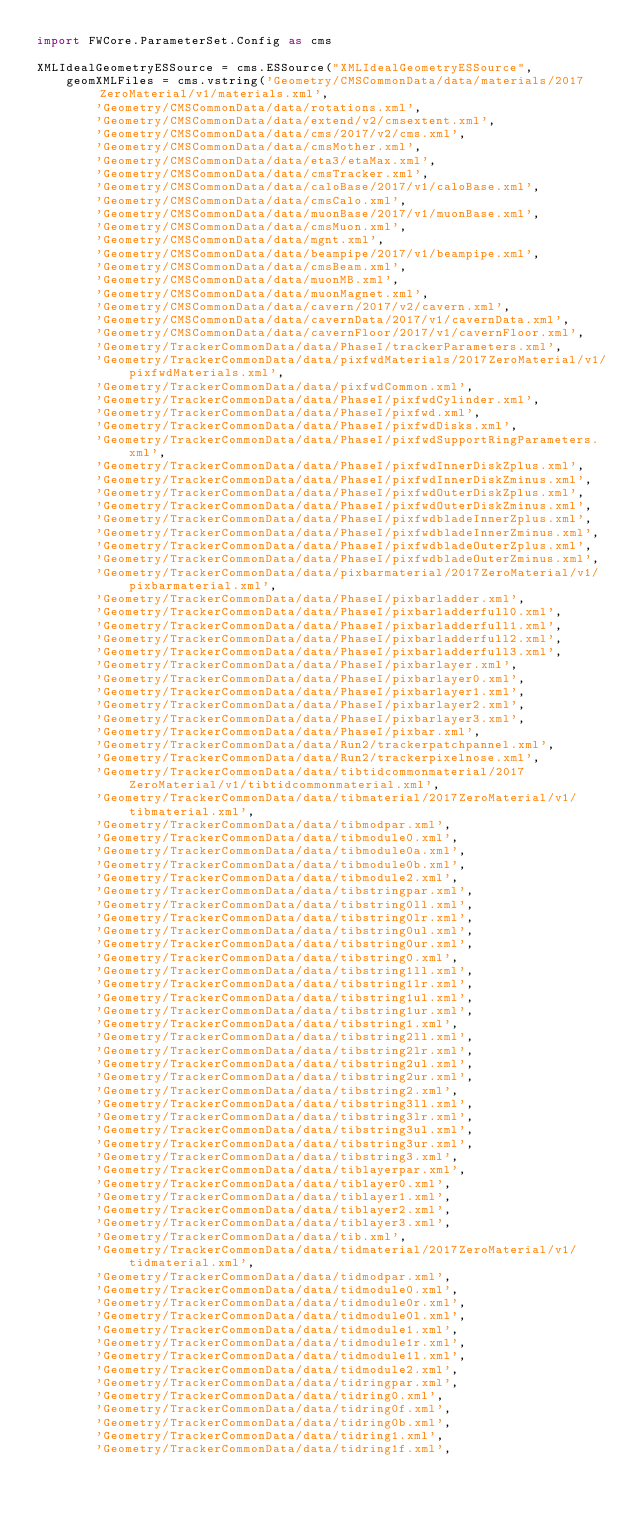<code> <loc_0><loc_0><loc_500><loc_500><_Python_>import FWCore.ParameterSet.Config as cms

XMLIdealGeometryESSource = cms.ESSource("XMLIdealGeometryESSource",
    geomXMLFiles = cms.vstring('Geometry/CMSCommonData/data/materials/2017ZeroMaterial/v1/materials.xml',
        'Geometry/CMSCommonData/data/rotations.xml',
        'Geometry/CMSCommonData/data/extend/v2/cmsextent.xml',
        'Geometry/CMSCommonData/data/cms/2017/v2/cms.xml',
        'Geometry/CMSCommonData/data/cmsMother.xml',
        'Geometry/CMSCommonData/data/eta3/etaMax.xml',
        'Geometry/CMSCommonData/data/cmsTracker.xml',
        'Geometry/CMSCommonData/data/caloBase/2017/v1/caloBase.xml',
        'Geometry/CMSCommonData/data/cmsCalo.xml',
        'Geometry/CMSCommonData/data/muonBase/2017/v1/muonBase.xml',
        'Geometry/CMSCommonData/data/cmsMuon.xml',
        'Geometry/CMSCommonData/data/mgnt.xml',
        'Geometry/CMSCommonData/data/beampipe/2017/v1/beampipe.xml',
        'Geometry/CMSCommonData/data/cmsBeam.xml',
        'Geometry/CMSCommonData/data/muonMB.xml',
        'Geometry/CMSCommonData/data/muonMagnet.xml',
        'Geometry/CMSCommonData/data/cavern/2017/v2/cavern.xml',
        'Geometry/CMSCommonData/data/cavernData/2017/v1/cavernData.xml',
        'Geometry/CMSCommonData/data/cavernFloor/2017/v1/cavernFloor.xml',
        'Geometry/TrackerCommonData/data/PhaseI/trackerParameters.xml',
        'Geometry/TrackerCommonData/data/pixfwdMaterials/2017ZeroMaterial/v1/pixfwdMaterials.xml',
        'Geometry/TrackerCommonData/data/pixfwdCommon.xml',
        'Geometry/TrackerCommonData/data/PhaseI/pixfwdCylinder.xml', 
        'Geometry/TrackerCommonData/data/PhaseI/pixfwd.xml', 
        'Geometry/TrackerCommonData/data/PhaseI/pixfwdDisks.xml', 
        'Geometry/TrackerCommonData/data/PhaseI/pixfwdSupportRingParameters.xml',
        'Geometry/TrackerCommonData/data/PhaseI/pixfwdInnerDiskZplus.xml',
        'Geometry/TrackerCommonData/data/PhaseI/pixfwdInnerDiskZminus.xml',
        'Geometry/TrackerCommonData/data/PhaseI/pixfwdOuterDiskZplus.xml',
        'Geometry/TrackerCommonData/data/PhaseI/pixfwdOuterDiskZminus.xml',
        'Geometry/TrackerCommonData/data/PhaseI/pixfwdbladeInnerZplus.xml',
        'Geometry/TrackerCommonData/data/PhaseI/pixfwdbladeInnerZminus.xml',
        'Geometry/TrackerCommonData/data/PhaseI/pixfwdbladeOuterZplus.xml',
        'Geometry/TrackerCommonData/data/PhaseI/pixfwdbladeOuterZminus.xml',
        'Geometry/TrackerCommonData/data/pixbarmaterial/2017ZeroMaterial/v1/pixbarmaterial.xml', 
        'Geometry/TrackerCommonData/data/PhaseI/pixbarladder.xml', 
        'Geometry/TrackerCommonData/data/PhaseI/pixbarladderfull0.xml', 
        'Geometry/TrackerCommonData/data/PhaseI/pixbarladderfull1.xml', 
        'Geometry/TrackerCommonData/data/PhaseI/pixbarladderfull2.xml', 
        'Geometry/TrackerCommonData/data/PhaseI/pixbarladderfull3.xml', 
        'Geometry/TrackerCommonData/data/PhaseI/pixbarlayer.xml', 
        'Geometry/TrackerCommonData/data/PhaseI/pixbarlayer0.xml', 
        'Geometry/TrackerCommonData/data/PhaseI/pixbarlayer1.xml', 
        'Geometry/TrackerCommonData/data/PhaseI/pixbarlayer2.xml', 
        'Geometry/TrackerCommonData/data/PhaseI/pixbarlayer3.xml', 
        'Geometry/TrackerCommonData/data/PhaseI/pixbar.xml',
        'Geometry/TrackerCommonData/data/Run2/trackerpatchpannel.xml',
        'Geometry/TrackerCommonData/data/Run2/trackerpixelnose.xml',
        'Geometry/TrackerCommonData/data/tibtidcommonmaterial/2017ZeroMaterial/v1/tibtidcommonmaterial.xml',
        'Geometry/TrackerCommonData/data/tibmaterial/2017ZeroMaterial/v1/tibmaterial.xml',
        'Geometry/TrackerCommonData/data/tibmodpar.xml',
        'Geometry/TrackerCommonData/data/tibmodule0.xml',
        'Geometry/TrackerCommonData/data/tibmodule0a.xml',
        'Geometry/TrackerCommonData/data/tibmodule0b.xml',
        'Geometry/TrackerCommonData/data/tibmodule2.xml',
        'Geometry/TrackerCommonData/data/tibstringpar.xml',
        'Geometry/TrackerCommonData/data/tibstring0ll.xml',
        'Geometry/TrackerCommonData/data/tibstring0lr.xml',
        'Geometry/TrackerCommonData/data/tibstring0ul.xml',
        'Geometry/TrackerCommonData/data/tibstring0ur.xml',
        'Geometry/TrackerCommonData/data/tibstring0.xml',
        'Geometry/TrackerCommonData/data/tibstring1ll.xml',
        'Geometry/TrackerCommonData/data/tibstring1lr.xml',
        'Geometry/TrackerCommonData/data/tibstring1ul.xml',
        'Geometry/TrackerCommonData/data/tibstring1ur.xml',
        'Geometry/TrackerCommonData/data/tibstring1.xml',
        'Geometry/TrackerCommonData/data/tibstring2ll.xml',
        'Geometry/TrackerCommonData/data/tibstring2lr.xml',
        'Geometry/TrackerCommonData/data/tibstring2ul.xml',
        'Geometry/TrackerCommonData/data/tibstring2ur.xml',
        'Geometry/TrackerCommonData/data/tibstring2.xml',
        'Geometry/TrackerCommonData/data/tibstring3ll.xml',
        'Geometry/TrackerCommonData/data/tibstring3lr.xml',
        'Geometry/TrackerCommonData/data/tibstring3ul.xml',
        'Geometry/TrackerCommonData/data/tibstring3ur.xml',
        'Geometry/TrackerCommonData/data/tibstring3.xml',
        'Geometry/TrackerCommonData/data/tiblayerpar.xml',
        'Geometry/TrackerCommonData/data/tiblayer0.xml',
        'Geometry/TrackerCommonData/data/tiblayer1.xml',
        'Geometry/TrackerCommonData/data/tiblayer2.xml',
        'Geometry/TrackerCommonData/data/tiblayer3.xml',
        'Geometry/TrackerCommonData/data/tib.xml',
        'Geometry/TrackerCommonData/data/tidmaterial/2017ZeroMaterial/v1/tidmaterial.xml',
        'Geometry/TrackerCommonData/data/tidmodpar.xml',
        'Geometry/TrackerCommonData/data/tidmodule0.xml',
        'Geometry/TrackerCommonData/data/tidmodule0r.xml',
        'Geometry/TrackerCommonData/data/tidmodule0l.xml',
        'Geometry/TrackerCommonData/data/tidmodule1.xml',
        'Geometry/TrackerCommonData/data/tidmodule1r.xml',
        'Geometry/TrackerCommonData/data/tidmodule1l.xml',
        'Geometry/TrackerCommonData/data/tidmodule2.xml',
        'Geometry/TrackerCommonData/data/tidringpar.xml',
        'Geometry/TrackerCommonData/data/tidring0.xml',
        'Geometry/TrackerCommonData/data/tidring0f.xml',
        'Geometry/TrackerCommonData/data/tidring0b.xml',
        'Geometry/TrackerCommonData/data/tidring1.xml',
        'Geometry/TrackerCommonData/data/tidring1f.xml',</code> 